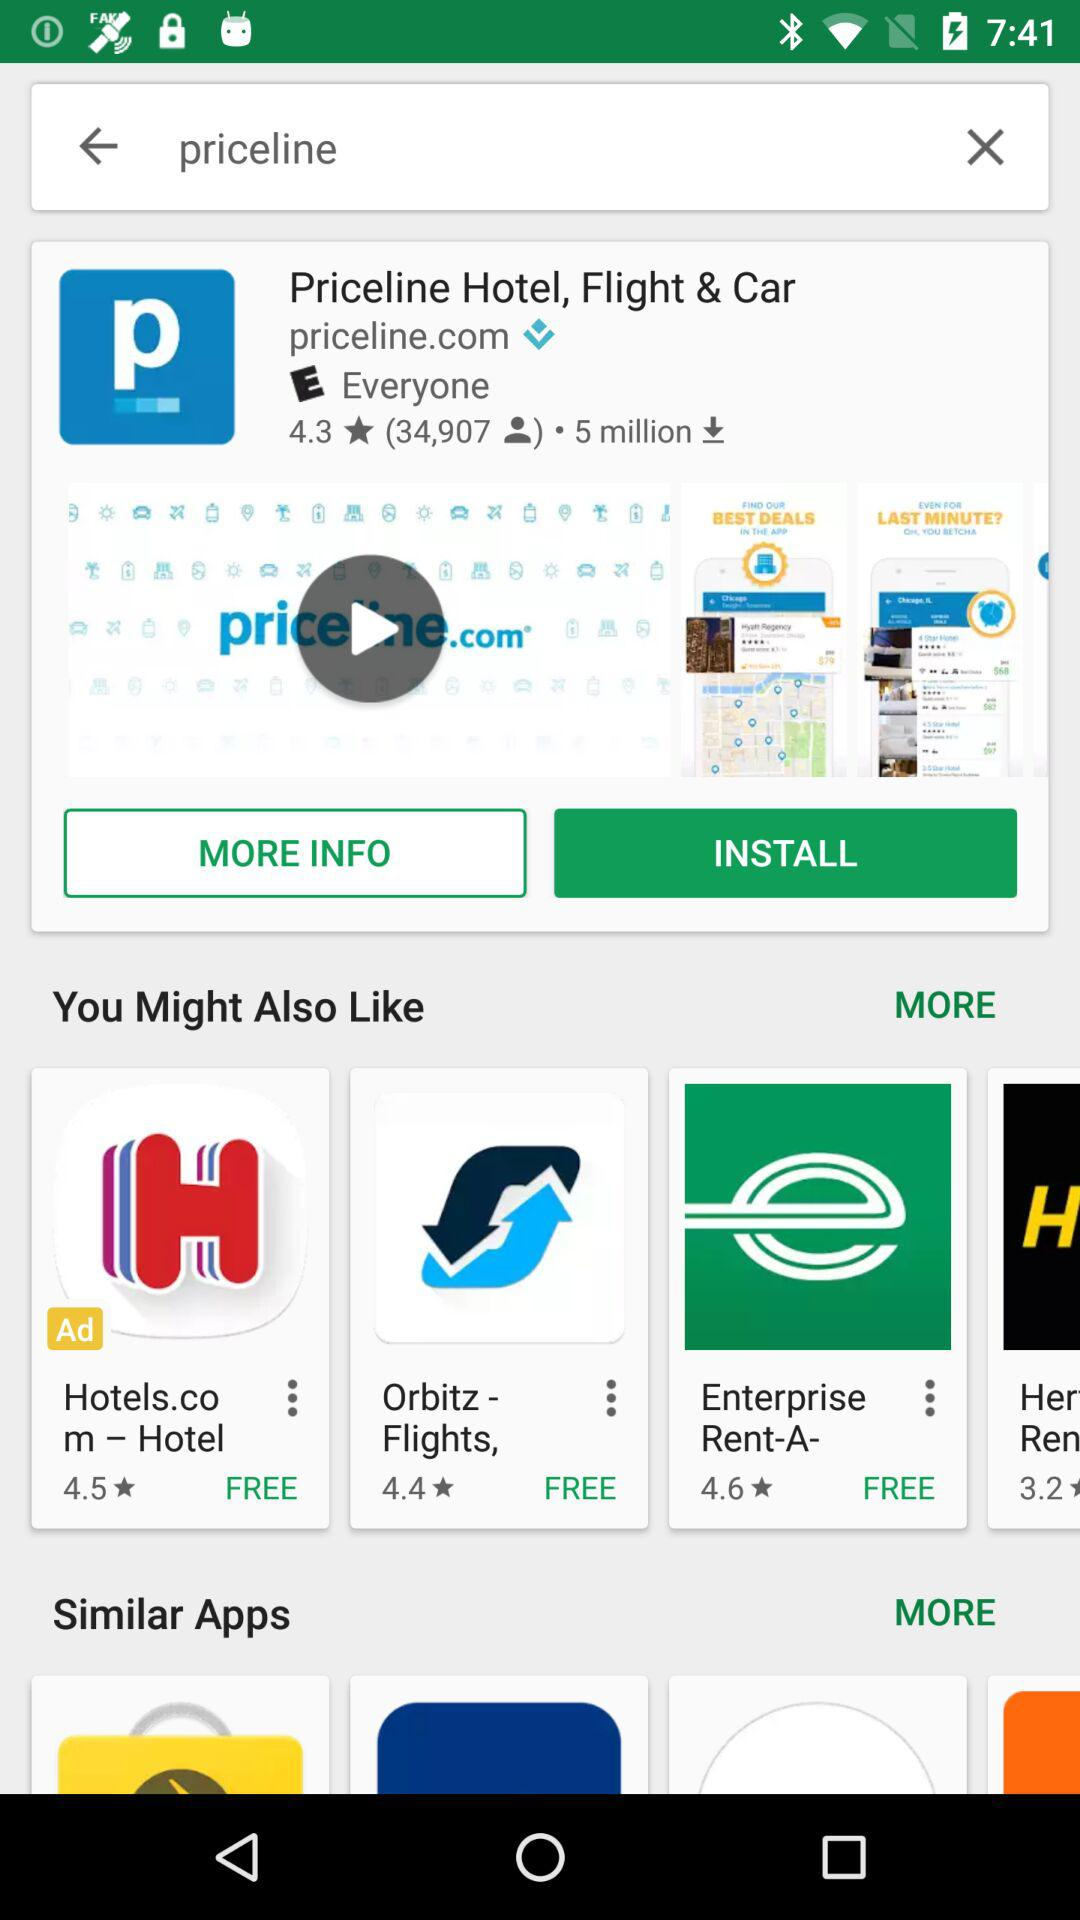What is the count of downloads of the Priceline hotel? The count of downloads is 5 million. 